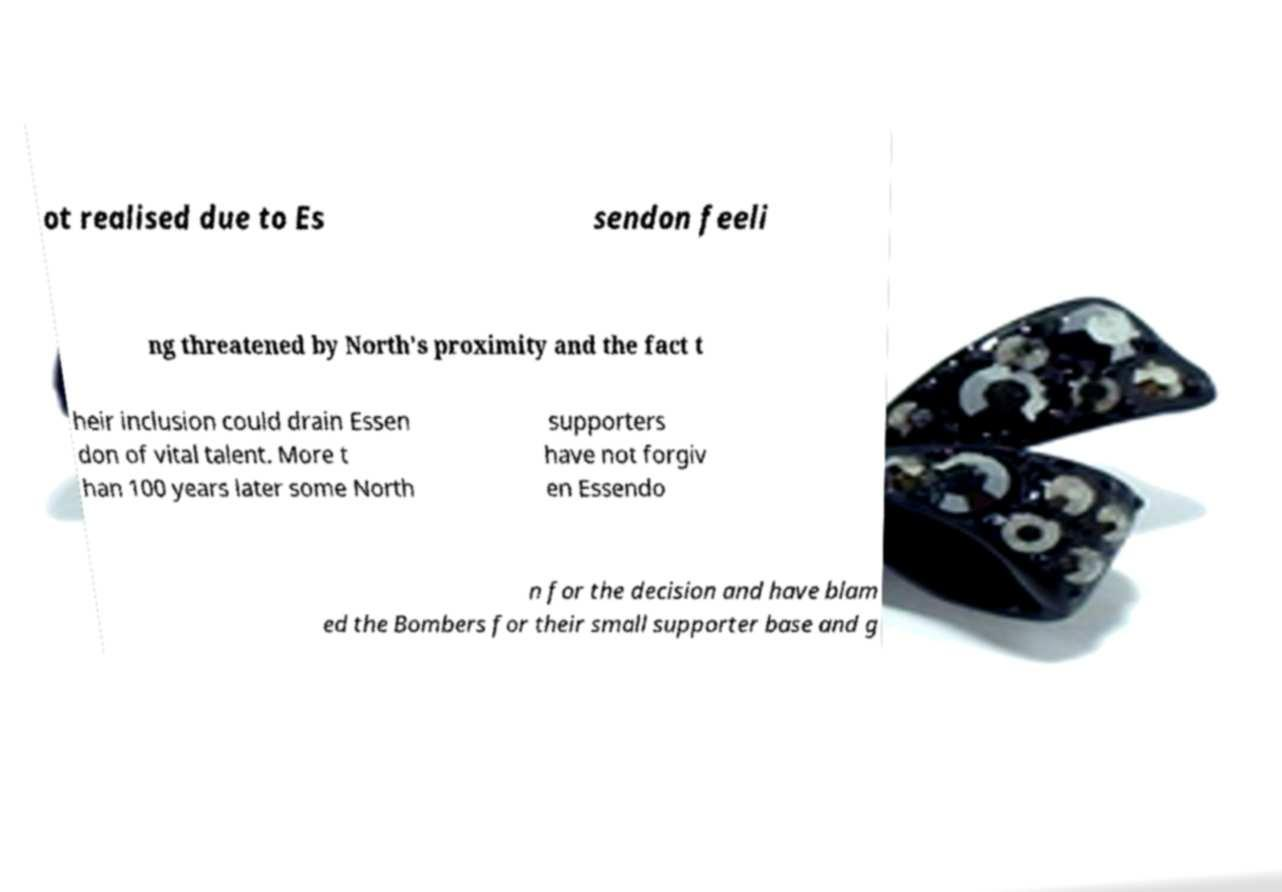Can you read and provide the text displayed in the image?This photo seems to have some interesting text. Can you extract and type it out for me? ot realised due to Es sendon feeli ng threatened by North's proximity and the fact t heir inclusion could drain Essen don of vital talent. More t han 100 years later some North supporters have not forgiv en Essendo n for the decision and have blam ed the Bombers for their small supporter base and g 